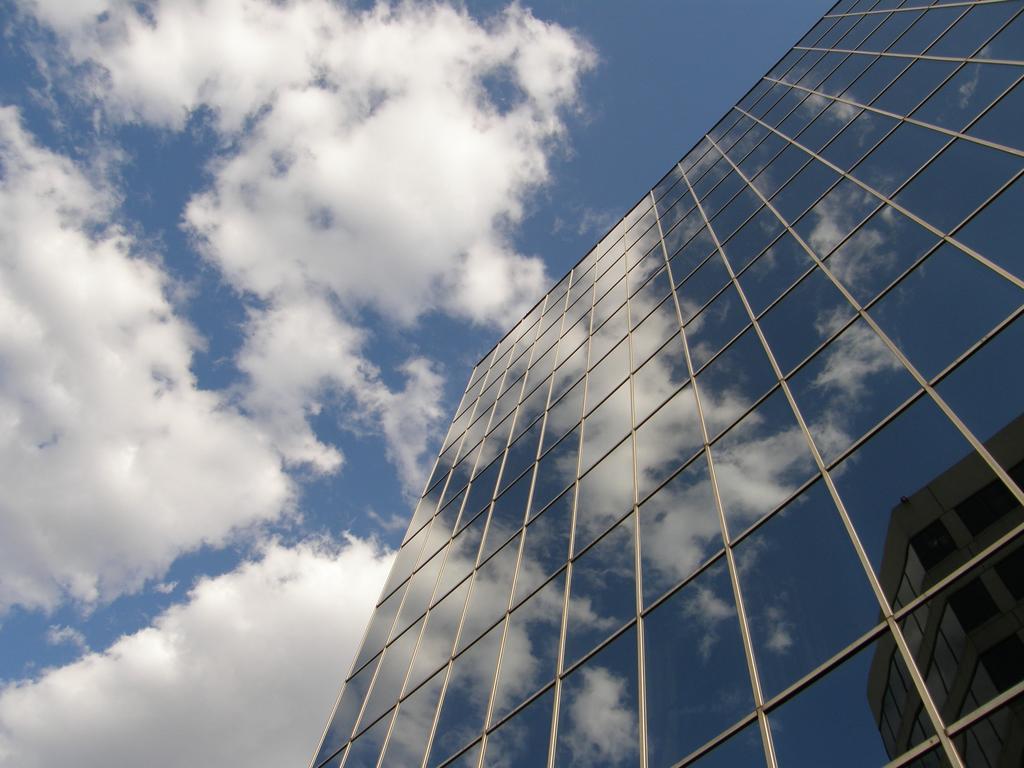How would you summarize this image in a sentence or two? In this picture we can see the view of a tall building made of glass from the bottom. The sky is blue. 